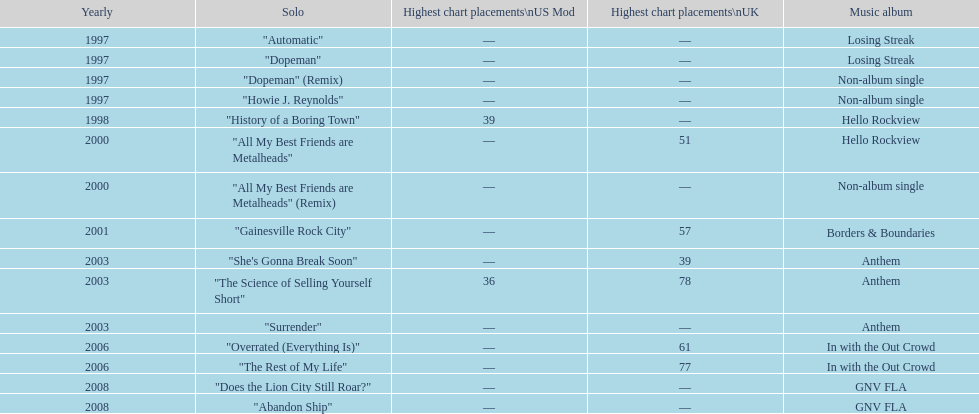What was the average chart position of their singles in the uk? 60.5. 